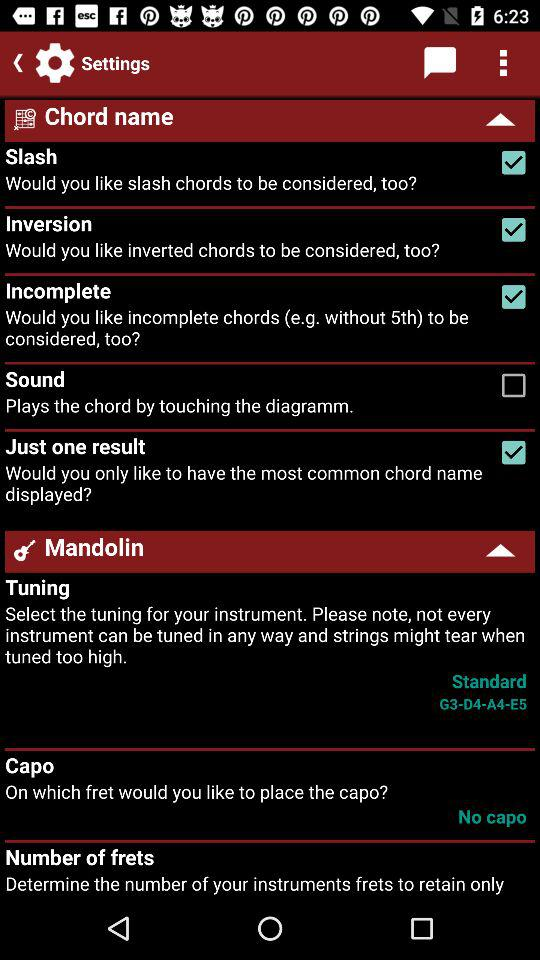What is the status of "Slash"? The status of "Slash" is "on". 